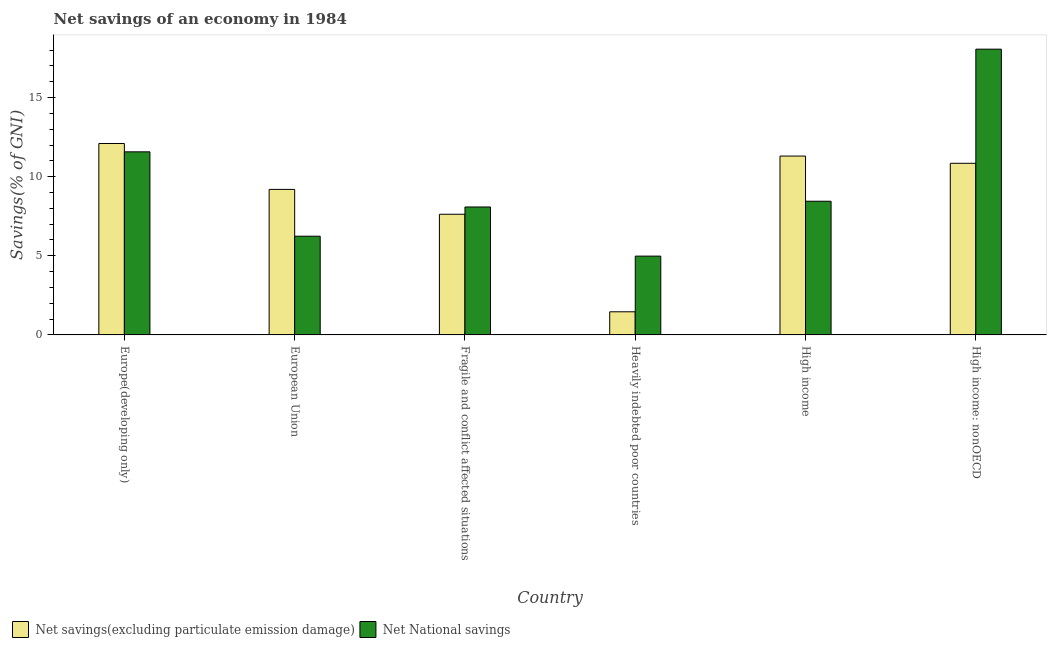Are the number of bars on each tick of the X-axis equal?
Offer a terse response. Yes. How many bars are there on the 6th tick from the right?
Ensure brevity in your answer.  2. What is the net national savings in Europe(developing only)?
Offer a terse response. 11.57. Across all countries, what is the maximum net savings(excluding particulate emission damage)?
Your response must be concise. 12.1. Across all countries, what is the minimum net national savings?
Your response must be concise. 4.98. In which country was the net national savings maximum?
Provide a short and direct response. High income: nonOECD. In which country was the net national savings minimum?
Make the answer very short. Heavily indebted poor countries. What is the total net savings(excluding particulate emission damage) in the graph?
Offer a very short reply. 52.53. What is the difference between the net savings(excluding particulate emission damage) in European Union and that in Fragile and conflict affected situations?
Offer a terse response. 1.57. What is the difference between the net national savings in High income and the net savings(excluding particulate emission damage) in Europe(developing only)?
Make the answer very short. -3.65. What is the average net savings(excluding particulate emission damage) per country?
Offer a very short reply. 8.76. What is the difference between the net national savings and net savings(excluding particulate emission damage) in Europe(developing only)?
Offer a terse response. -0.53. What is the ratio of the net national savings in Europe(developing only) to that in European Union?
Keep it short and to the point. 1.85. What is the difference between the highest and the second highest net national savings?
Offer a terse response. 6.49. What is the difference between the highest and the lowest net national savings?
Provide a short and direct response. 13.08. In how many countries, is the net savings(excluding particulate emission damage) greater than the average net savings(excluding particulate emission damage) taken over all countries?
Give a very brief answer. 4. What does the 1st bar from the left in European Union represents?
Ensure brevity in your answer.  Net savings(excluding particulate emission damage). What does the 2nd bar from the right in High income: nonOECD represents?
Keep it short and to the point. Net savings(excluding particulate emission damage). Are all the bars in the graph horizontal?
Provide a short and direct response. No. How many countries are there in the graph?
Give a very brief answer. 6. What is the title of the graph?
Make the answer very short. Net savings of an economy in 1984. What is the label or title of the Y-axis?
Your response must be concise. Savings(% of GNI). What is the Savings(% of GNI) of Net savings(excluding particulate emission damage) in Europe(developing only)?
Make the answer very short. 12.1. What is the Savings(% of GNI) in Net National savings in Europe(developing only)?
Offer a terse response. 11.57. What is the Savings(% of GNI) of Net savings(excluding particulate emission damage) in European Union?
Your response must be concise. 9.2. What is the Savings(% of GNI) in Net National savings in European Union?
Keep it short and to the point. 6.24. What is the Savings(% of GNI) in Net savings(excluding particulate emission damage) in Fragile and conflict affected situations?
Provide a succinct answer. 7.63. What is the Savings(% of GNI) of Net National savings in Fragile and conflict affected situations?
Your answer should be compact. 8.09. What is the Savings(% of GNI) of Net savings(excluding particulate emission damage) in Heavily indebted poor countries?
Make the answer very short. 1.46. What is the Savings(% of GNI) in Net National savings in Heavily indebted poor countries?
Keep it short and to the point. 4.98. What is the Savings(% of GNI) of Net savings(excluding particulate emission damage) in High income?
Offer a terse response. 11.3. What is the Savings(% of GNI) of Net National savings in High income?
Provide a short and direct response. 8.45. What is the Savings(% of GNI) of Net savings(excluding particulate emission damage) in High income: nonOECD?
Offer a very short reply. 10.85. What is the Savings(% of GNI) in Net National savings in High income: nonOECD?
Offer a very short reply. 18.06. Across all countries, what is the maximum Savings(% of GNI) in Net savings(excluding particulate emission damage)?
Offer a very short reply. 12.1. Across all countries, what is the maximum Savings(% of GNI) of Net National savings?
Your response must be concise. 18.06. Across all countries, what is the minimum Savings(% of GNI) in Net savings(excluding particulate emission damage)?
Give a very brief answer. 1.46. Across all countries, what is the minimum Savings(% of GNI) of Net National savings?
Ensure brevity in your answer.  4.98. What is the total Savings(% of GNI) of Net savings(excluding particulate emission damage) in the graph?
Offer a very short reply. 52.53. What is the total Savings(% of GNI) of Net National savings in the graph?
Provide a short and direct response. 57.38. What is the difference between the Savings(% of GNI) of Net savings(excluding particulate emission damage) in Europe(developing only) and that in European Union?
Ensure brevity in your answer.  2.9. What is the difference between the Savings(% of GNI) in Net National savings in Europe(developing only) and that in European Union?
Keep it short and to the point. 5.33. What is the difference between the Savings(% of GNI) of Net savings(excluding particulate emission damage) in Europe(developing only) and that in Fragile and conflict affected situations?
Provide a short and direct response. 4.47. What is the difference between the Savings(% of GNI) in Net National savings in Europe(developing only) and that in Fragile and conflict affected situations?
Your answer should be compact. 3.49. What is the difference between the Savings(% of GNI) of Net savings(excluding particulate emission damage) in Europe(developing only) and that in Heavily indebted poor countries?
Provide a short and direct response. 10.64. What is the difference between the Savings(% of GNI) of Net National savings in Europe(developing only) and that in Heavily indebted poor countries?
Provide a short and direct response. 6.59. What is the difference between the Savings(% of GNI) in Net savings(excluding particulate emission damage) in Europe(developing only) and that in High income?
Offer a terse response. 0.79. What is the difference between the Savings(% of GNI) of Net National savings in Europe(developing only) and that in High income?
Your answer should be compact. 3.12. What is the difference between the Savings(% of GNI) in Net savings(excluding particulate emission damage) in Europe(developing only) and that in High income: nonOECD?
Provide a short and direct response. 1.25. What is the difference between the Savings(% of GNI) in Net National savings in Europe(developing only) and that in High income: nonOECD?
Your answer should be compact. -6.49. What is the difference between the Savings(% of GNI) in Net savings(excluding particulate emission damage) in European Union and that in Fragile and conflict affected situations?
Your answer should be compact. 1.57. What is the difference between the Savings(% of GNI) in Net National savings in European Union and that in Fragile and conflict affected situations?
Make the answer very short. -1.85. What is the difference between the Savings(% of GNI) in Net savings(excluding particulate emission damage) in European Union and that in Heavily indebted poor countries?
Your answer should be compact. 7.74. What is the difference between the Savings(% of GNI) in Net National savings in European Union and that in Heavily indebted poor countries?
Your answer should be compact. 1.26. What is the difference between the Savings(% of GNI) of Net savings(excluding particulate emission damage) in European Union and that in High income?
Make the answer very short. -2.11. What is the difference between the Savings(% of GNI) of Net National savings in European Union and that in High income?
Ensure brevity in your answer.  -2.21. What is the difference between the Savings(% of GNI) in Net savings(excluding particulate emission damage) in European Union and that in High income: nonOECD?
Keep it short and to the point. -1.65. What is the difference between the Savings(% of GNI) in Net National savings in European Union and that in High income: nonOECD?
Ensure brevity in your answer.  -11.82. What is the difference between the Savings(% of GNI) of Net savings(excluding particulate emission damage) in Fragile and conflict affected situations and that in Heavily indebted poor countries?
Offer a terse response. 6.16. What is the difference between the Savings(% of GNI) of Net National savings in Fragile and conflict affected situations and that in Heavily indebted poor countries?
Your answer should be very brief. 3.11. What is the difference between the Savings(% of GNI) in Net savings(excluding particulate emission damage) in Fragile and conflict affected situations and that in High income?
Make the answer very short. -3.68. What is the difference between the Savings(% of GNI) of Net National savings in Fragile and conflict affected situations and that in High income?
Your answer should be very brief. -0.36. What is the difference between the Savings(% of GNI) of Net savings(excluding particulate emission damage) in Fragile and conflict affected situations and that in High income: nonOECD?
Make the answer very short. -3.22. What is the difference between the Savings(% of GNI) of Net National savings in Fragile and conflict affected situations and that in High income: nonOECD?
Your response must be concise. -9.97. What is the difference between the Savings(% of GNI) of Net savings(excluding particulate emission damage) in Heavily indebted poor countries and that in High income?
Provide a short and direct response. -9.84. What is the difference between the Savings(% of GNI) in Net National savings in Heavily indebted poor countries and that in High income?
Give a very brief answer. -3.47. What is the difference between the Savings(% of GNI) of Net savings(excluding particulate emission damage) in Heavily indebted poor countries and that in High income: nonOECD?
Give a very brief answer. -9.39. What is the difference between the Savings(% of GNI) of Net National savings in Heavily indebted poor countries and that in High income: nonOECD?
Offer a very short reply. -13.08. What is the difference between the Savings(% of GNI) of Net savings(excluding particulate emission damage) in High income and that in High income: nonOECD?
Your answer should be compact. 0.46. What is the difference between the Savings(% of GNI) of Net National savings in High income and that in High income: nonOECD?
Offer a terse response. -9.61. What is the difference between the Savings(% of GNI) of Net savings(excluding particulate emission damage) in Europe(developing only) and the Savings(% of GNI) of Net National savings in European Union?
Provide a succinct answer. 5.86. What is the difference between the Savings(% of GNI) of Net savings(excluding particulate emission damage) in Europe(developing only) and the Savings(% of GNI) of Net National savings in Fragile and conflict affected situations?
Give a very brief answer. 4.01. What is the difference between the Savings(% of GNI) in Net savings(excluding particulate emission damage) in Europe(developing only) and the Savings(% of GNI) in Net National savings in Heavily indebted poor countries?
Offer a terse response. 7.12. What is the difference between the Savings(% of GNI) in Net savings(excluding particulate emission damage) in Europe(developing only) and the Savings(% of GNI) in Net National savings in High income?
Provide a succinct answer. 3.65. What is the difference between the Savings(% of GNI) of Net savings(excluding particulate emission damage) in Europe(developing only) and the Savings(% of GNI) of Net National savings in High income: nonOECD?
Provide a short and direct response. -5.96. What is the difference between the Savings(% of GNI) in Net savings(excluding particulate emission damage) in European Union and the Savings(% of GNI) in Net National savings in Fragile and conflict affected situations?
Give a very brief answer. 1.11. What is the difference between the Savings(% of GNI) in Net savings(excluding particulate emission damage) in European Union and the Savings(% of GNI) in Net National savings in Heavily indebted poor countries?
Give a very brief answer. 4.22. What is the difference between the Savings(% of GNI) of Net savings(excluding particulate emission damage) in European Union and the Savings(% of GNI) of Net National savings in High income?
Provide a succinct answer. 0.75. What is the difference between the Savings(% of GNI) in Net savings(excluding particulate emission damage) in European Union and the Savings(% of GNI) in Net National savings in High income: nonOECD?
Provide a succinct answer. -8.86. What is the difference between the Savings(% of GNI) of Net savings(excluding particulate emission damage) in Fragile and conflict affected situations and the Savings(% of GNI) of Net National savings in Heavily indebted poor countries?
Your answer should be very brief. 2.65. What is the difference between the Savings(% of GNI) in Net savings(excluding particulate emission damage) in Fragile and conflict affected situations and the Savings(% of GNI) in Net National savings in High income?
Make the answer very short. -0.82. What is the difference between the Savings(% of GNI) in Net savings(excluding particulate emission damage) in Fragile and conflict affected situations and the Savings(% of GNI) in Net National savings in High income: nonOECD?
Give a very brief answer. -10.43. What is the difference between the Savings(% of GNI) in Net savings(excluding particulate emission damage) in Heavily indebted poor countries and the Savings(% of GNI) in Net National savings in High income?
Your answer should be compact. -6.99. What is the difference between the Savings(% of GNI) of Net savings(excluding particulate emission damage) in Heavily indebted poor countries and the Savings(% of GNI) of Net National savings in High income: nonOECD?
Provide a short and direct response. -16.6. What is the difference between the Savings(% of GNI) in Net savings(excluding particulate emission damage) in High income and the Savings(% of GNI) in Net National savings in High income: nonOECD?
Ensure brevity in your answer.  -6.76. What is the average Savings(% of GNI) of Net savings(excluding particulate emission damage) per country?
Your response must be concise. 8.76. What is the average Savings(% of GNI) of Net National savings per country?
Provide a short and direct response. 9.56. What is the difference between the Savings(% of GNI) of Net savings(excluding particulate emission damage) and Savings(% of GNI) of Net National savings in Europe(developing only)?
Keep it short and to the point. 0.53. What is the difference between the Savings(% of GNI) in Net savings(excluding particulate emission damage) and Savings(% of GNI) in Net National savings in European Union?
Ensure brevity in your answer.  2.96. What is the difference between the Savings(% of GNI) in Net savings(excluding particulate emission damage) and Savings(% of GNI) in Net National savings in Fragile and conflict affected situations?
Your answer should be compact. -0.46. What is the difference between the Savings(% of GNI) in Net savings(excluding particulate emission damage) and Savings(% of GNI) in Net National savings in Heavily indebted poor countries?
Make the answer very short. -3.52. What is the difference between the Savings(% of GNI) of Net savings(excluding particulate emission damage) and Savings(% of GNI) of Net National savings in High income?
Your answer should be compact. 2.86. What is the difference between the Savings(% of GNI) of Net savings(excluding particulate emission damage) and Savings(% of GNI) of Net National savings in High income: nonOECD?
Ensure brevity in your answer.  -7.21. What is the ratio of the Savings(% of GNI) of Net savings(excluding particulate emission damage) in Europe(developing only) to that in European Union?
Your answer should be compact. 1.32. What is the ratio of the Savings(% of GNI) of Net National savings in Europe(developing only) to that in European Union?
Ensure brevity in your answer.  1.85. What is the ratio of the Savings(% of GNI) of Net savings(excluding particulate emission damage) in Europe(developing only) to that in Fragile and conflict affected situations?
Offer a very short reply. 1.59. What is the ratio of the Savings(% of GNI) of Net National savings in Europe(developing only) to that in Fragile and conflict affected situations?
Your response must be concise. 1.43. What is the ratio of the Savings(% of GNI) in Net savings(excluding particulate emission damage) in Europe(developing only) to that in Heavily indebted poor countries?
Keep it short and to the point. 8.28. What is the ratio of the Savings(% of GNI) of Net National savings in Europe(developing only) to that in Heavily indebted poor countries?
Offer a very short reply. 2.32. What is the ratio of the Savings(% of GNI) in Net savings(excluding particulate emission damage) in Europe(developing only) to that in High income?
Offer a terse response. 1.07. What is the ratio of the Savings(% of GNI) of Net National savings in Europe(developing only) to that in High income?
Make the answer very short. 1.37. What is the ratio of the Savings(% of GNI) of Net savings(excluding particulate emission damage) in Europe(developing only) to that in High income: nonOECD?
Offer a very short reply. 1.12. What is the ratio of the Savings(% of GNI) of Net National savings in Europe(developing only) to that in High income: nonOECD?
Your answer should be very brief. 0.64. What is the ratio of the Savings(% of GNI) in Net savings(excluding particulate emission damage) in European Union to that in Fragile and conflict affected situations?
Provide a short and direct response. 1.21. What is the ratio of the Savings(% of GNI) of Net National savings in European Union to that in Fragile and conflict affected situations?
Your response must be concise. 0.77. What is the ratio of the Savings(% of GNI) in Net savings(excluding particulate emission damage) in European Union to that in Heavily indebted poor countries?
Ensure brevity in your answer.  6.29. What is the ratio of the Savings(% of GNI) of Net National savings in European Union to that in Heavily indebted poor countries?
Make the answer very short. 1.25. What is the ratio of the Savings(% of GNI) in Net savings(excluding particulate emission damage) in European Union to that in High income?
Give a very brief answer. 0.81. What is the ratio of the Savings(% of GNI) in Net National savings in European Union to that in High income?
Offer a terse response. 0.74. What is the ratio of the Savings(% of GNI) of Net savings(excluding particulate emission damage) in European Union to that in High income: nonOECD?
Provide a succinct answer. 0.85. What is the ratio of the Savings(% of GNI) of Net National savings in European Union to that in High income: nonOECD?
Your response must be concise. 0.35. What is the ratio of the Savings(% of GNI) of Net savings(excluding particulate emission damage) in Fragile and conflict affected situations to that in Heavily indebted poor countries?
Keep it short and to the point. 5.22. What is the ratio of the Savings(% of GNI) of Net National savings in Fragile and conflict affected situations to that in Heavily indebted poor countries?
Keep it short and to the point. 1.62. What is the ratio of the Savings(% of GNI) of Net savings(excluding particulate emission damage) in Fragile and conflict affected situations to that in High income?
Offer a very short reply. 0.67. What is the ratio of the Savings(% of GNI) in Net National savings in Fragile and conflict affected situations to that in High income?
Keep it short and to the point. 0.96. What is the ratio of the Savings(% of GNI) of Net savings(excluding particulate emission damage) in Fragile and conflict affected situations to that in High income: nonOECD?
Offer a terse response. 0.7. What is the ratio of the Savings(% of GNI) in Net National savings in Fragile and conflict affected situations to that in High income: nonOECD?
Ensure brevity in your answer.  0.45. What is the ratio of the Savings(% of GNI) in Net savings(excluding particulate emission damage) in Heavily indebted poor countries to that in High income?
Keep it short and to the point. 0.13. What is the ratio of the Savings(% of GNI) in Net National savings in Heavily indebted poor countries to that in High income?
Give a very brief answer. 0.59. What is the ratio of the Savings(% of GNI) of Net savings(excluding particulate emission damage) in Heavily indebted poor countries to that in High income: nonOECD?
Your response must be concise. 0.13. What is the ratio of the Savings(% of GNI) of Net National savings in Heavily indebted poor countries to that in High income: nonOECD?
Offer a terse response. 0.28. What is the ratio of the Savings(% of GNI) of Net savings(excluding particulate emission damage) in High income to that in High income: nonOECD?
Your response must be concise. 1.04. What is the ratio of the Savings(% of GNI) of Net National savings in High income to that in High income: nonOECD?
Your answer should be very brief. 0.47. What is the difference between the highest and the second highest Savings(% of GNI) of Net savings(excluding particulate emission damage)?
Offer a terse response. 0.79. What is the difference between the highest and the second highest Savings(% of GNI) of Net National savings?
Make the answer very short. 6.49. What is the difference between the highest and the lowest Savings(% of GNI) in Net savings(excluding particulate emission damage)?
Your response must be concise. 10.64. What is the difference between the highest and the lowest Savings(% of GNI) of Net National savings?
Provide a short and direct response. 13.08. 